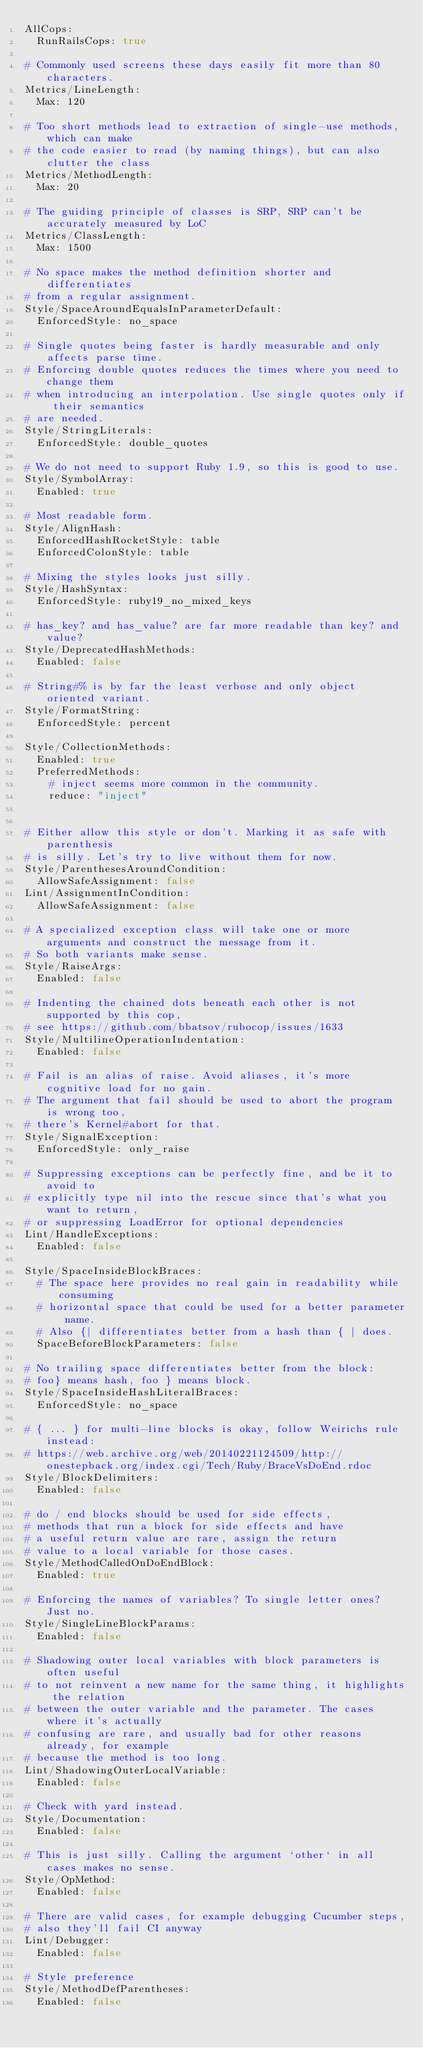<code> <loc_0><loc_0><loc_500><loc_500><_YAML_>AllCops:
  RunRailsCops: true

# Commonly used screens these days easily fit more than 80 characters.
Metrics/LineLength:
  Max: 120

# Too short methods lead to extraction of single-use methods, which can make
# the code easier to read (by naming things), but can also clutter the class
Metrics/MethodLength: 
  Max: 20

# The guiding principle of classes is SRP, SRP can't be accurately measured by LoC
Metrics/ClassLength:
  Max: 1500

# No space makes the method definition shorter and differentiates
# from a regular assignment.
Style/SpaceAroundEqualsInParameterDefault:
  EnforcedStyle: no_space

# Single quotes being faster is hardly measurable and only affects parse time.
# Enforcing double quotes reduces the times where you need to change them
# when introducing an interpolation. Use single quotes only if their semantics
# are needed.
Style/StringLiterals:
  EnforcedStyle: double_quotes

# We do not need to support Ruby 1.9, so this is good to use.
Style/SymbolArray:
  Enabled: true

# Most readable form.
Style/AlignHash:
  EnforcedHashRocketStyle: table
  EnforcedColonStyle: table

# Mixing the styles looks just silly.
Style/HashSyntax:
  EnforcedStyle: ruby19_no_mixed_keys

# has_key? and has_value? are far more readable than key? and value?
Style/DeprecatedHashMethods:
  Enabled: false

# String#% is by far the least verbose and only object oriented variant.
Style/FormatString:
  EnforcedStyle: percent

Style/CollectionMethods:
  Enabled: true
  PreferredMethods:
    # inject seems more common in the community.
    reduce: "inject"


# Either allow this style or don't. Marking it as safe with parenthesis
# is silly. Let's try to live without them for now.
Style/ParenthesesAroundCondition:
  AllowSafeAssignment: false
Lint/AssignmentInCondition:
  AllowSafeAssignment: false

# A specialized exception class will take one or more arguments and construct the message from it.
# So both variants make sense. 
Style/RaiseArgs:
  Enabled: false

# Indenting the chained dots beneath each other is not supported by this cop,
# see https://github.com/bbatsov/rubocop/issues/1633
Style/MultilineOperationIndentation:
  Enabled: false

# Fail is an alias of raise. Avoid aliases, it's more cognitive load for no gain.
# The argument that fail should be used to abort the program is wrong too,
# there's Kernel#abort for that.
Style/SignalException:
  EnforcedStyle: only_raise

# Suppressing exceptions can be perfectly fine, and be it to avoid to
# explicitly type nil into the rescue since that's what you want to return,
# or suppressing LoadError for optional dependencies
Lint/HandleExceptions:
  Enabled: false

Style/SpaceInsideBlockBraces:
  # The space here provides no real gain in readability while consuming
  # horizontal space that could be used for a better parameter name.
  # Also {| differentiates better from a hash than { | does.
  SpaceBeforeBlockParameters: false

# No trailing space differentiates better from the block:
# foo} means hash, foo } means block.
Style/SpaceInsideHashLiteralBraces:
  EnforcedStyle: no_space

# { ... } for multi-line blocks is okay, follow Weirichs rule instead:
# https://web.archive.org/web/20140221124509/http://onestepback.org/index.cgi/Tech/Ruby/BraceVsDoEnd.rdoc
Style/BlockDelimiters:
  Enabled: false

# do / end blocks should be used for side effects,
# methods that run a block for side effects and have
# a useful return value are rare, assign the return
# value to a local variable for those cases.
Style/MethodCalledOnDoEndBlock:
  Enabled: true

# Enforcing the names of variables? To single letter ones? Just no.
Style/SingleLineBlockParams:
  Enabled: false

# Shadowing outer local variables with block parameters is often useful
# to not reinvent a new name for the same thing, it highlights the relation
# between the outer variable and the parameter. The cases where it's actually
# confusing are rare, and usually bad for other reasons already, for example
# because the method is too long.
Lint/ShadowingOuterLocalVariable:
  Enabled: false

# Check with yard instead.
Style/Documentation:
  Enabled: false 

# This is just silly. Calling the argument `other` in all cases makes no sense.
Style/OpMethod:
  Enabled: false 

# There are valid cases, for example debugging Cucumber steps,
# also they'll fail CI anyway
Lint/Debugger:
  Enabled: false

# Style preference
Style/MethodDefParentheses:
  Enabled: false
</code> 